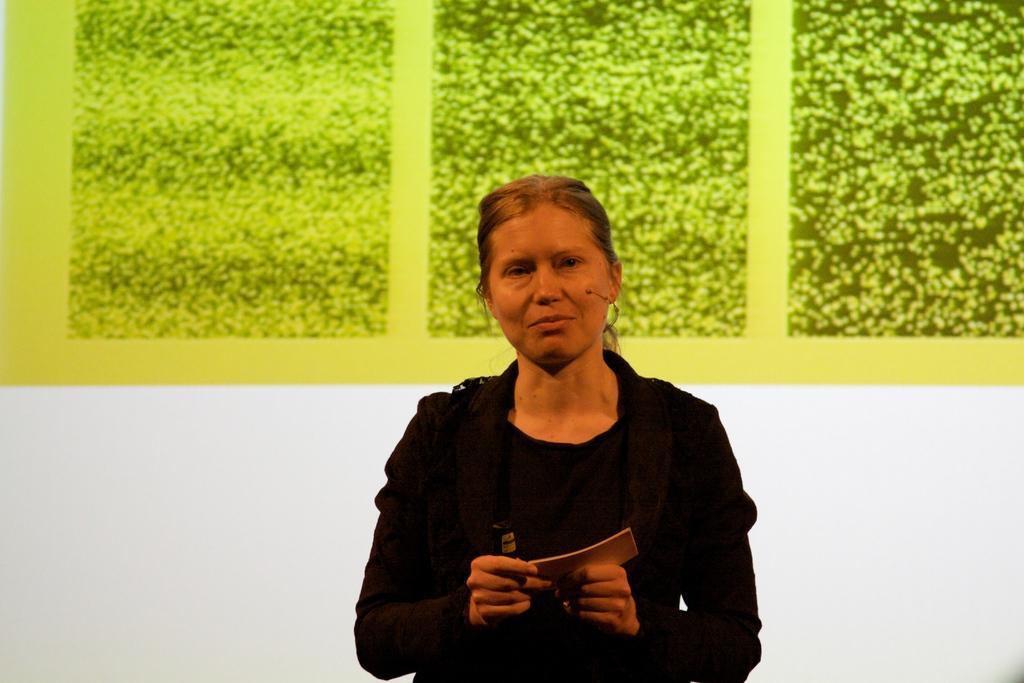In one or two sentences, can you explain what this image depicts? In this image in the front there is a woman standing and holding a book in her hand and there is a black colour object in her hand. In the background there is a wall, on the wall there is a green colour object. 